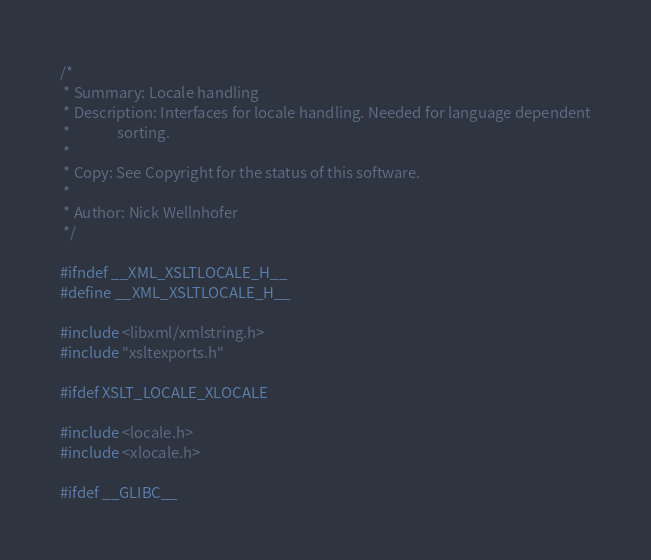<code> <loc_0><loc_0><loc_500><loc_500><_C_>/*
 * Summary: Locale handling
 * Description: Interfaces for locale handling. Needed for language dependent
 *              sorting.
 *
 * Copy: See Copyright for the status of this software.
 *
 * Author: Nick Wellnhofer
 */

#ifndef __XML_XSLTLOCALE_H__
#define __XML_XSLTLOCALE_H__

#include <libxml/xmlstring.h>
#include "xsltexports.h"

#ifdef XSLT_LOCALE_XLOCALE

#include <locale.h>
#include <xlocale.h>

#ifdef __GLIBC__</code> 